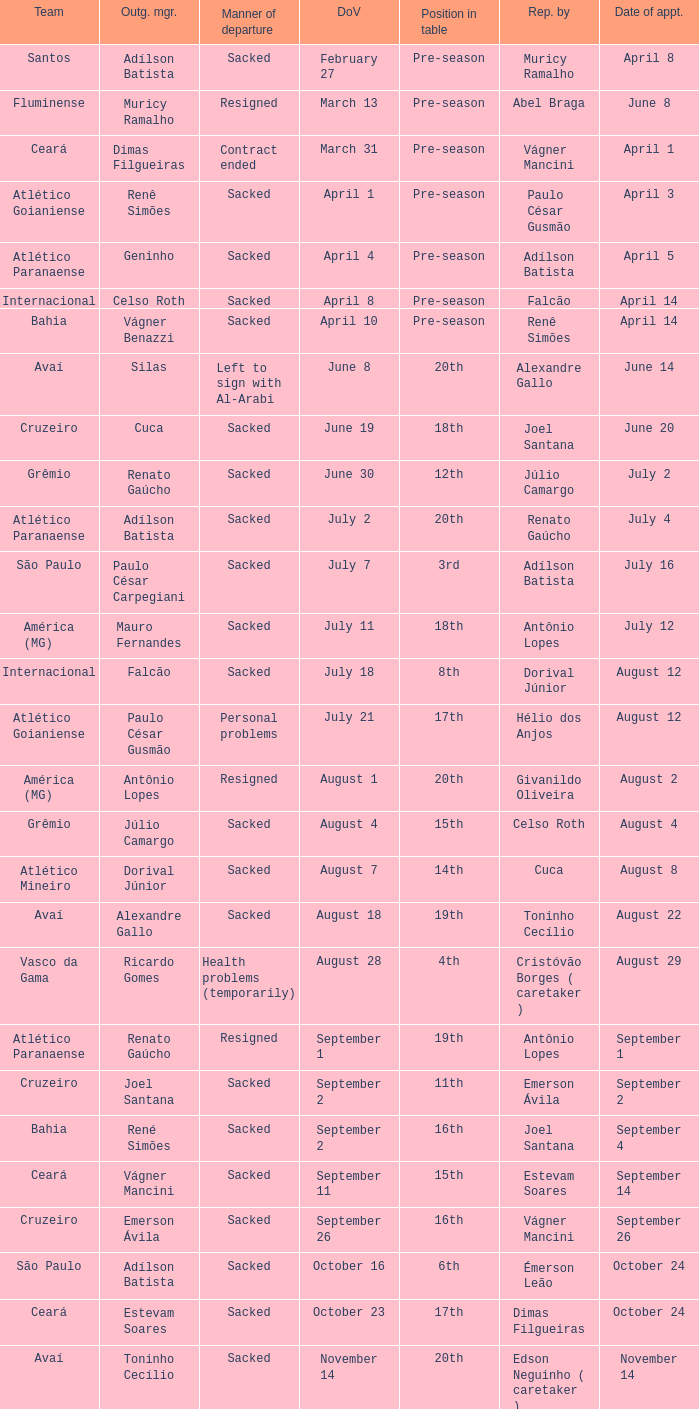How many times did Silas leave as a team manager? 1.0. 